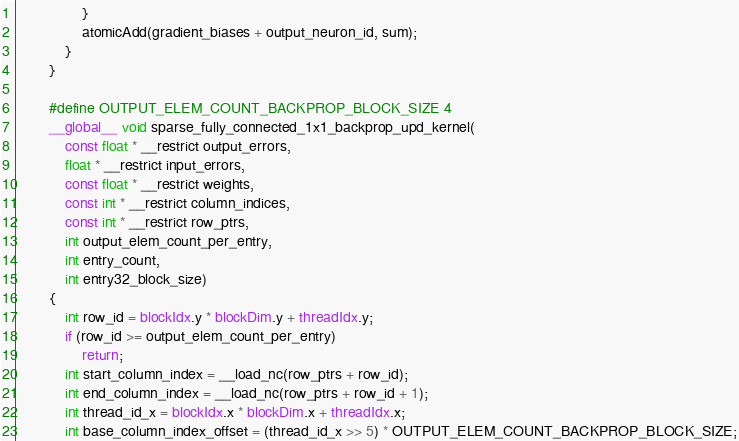Convert code to text. <code><loc_0><loc_0><loc_500><loc_500><_Cuda_>				}
				atomicAdd(gradient_biases + output_neuron_id, sum);
			}
		}

		#define OUTPUT_ELEM_COUNT_BACKPROP_BLOCK_SIZE 4
		__global__ void sparse_fully_connected_1x1_backprop_upd_kernel(
			const float * __restrict output_errors,
			float * __restrict input_errors,
			const float * __restrict weights,
			const int * __restrict column_indices,
			const int * __restrict row_ptrs,
			int output_elem_count_per_entry,
			int entry_count,
			int entry32_block_size)
		{
			int row_id = blockIdx.y * blockDim.y + threadIdx.y;
			if (row_id >= output_elem_count_per_entry)
				return;
			int start_column_index = __load_nc(row_ptrs + row_id);
			int end_column_index = __load_nc(row_ptrs + row_id + 1);
			int thread_id_x = blockIdx.x * blockDim.x + threadIdx.x;
			int base_column_index_offset = (thread_id_x >> 5) * OUTPUT_ELEM_COUNT_BACKPROP_BLOCK_SIZE;</code> 